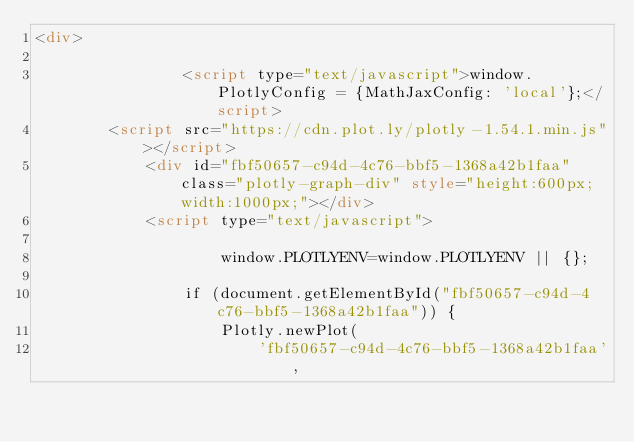<code> <loc_0><loc_0><loc_500><loc_500><_HTML_><div>
        
                <script type="text/javascript">window.PlotlyConfig = {MathJaxConfig: 'local'};</script>
        <script src="https://cdn.plot.ly/plotly-1.54.1.min.js"></script>    
            <div id="fbf50657-c94d-4c76-bbf5-1368a42b1faa" class="plotly-graph-div" style="height:600px; width:1000px;"></div>
            <script type="text/javascript">
                
                    window.PLOTLYENV=window.PLOTLYENV || {};
                    
                if (document.getElementById("fbf50657-c94d-4c76-bbf5-1368a42b1faa")) {
                    Plotly.newPlot(
                        'fbf50657-c94d-4c76-bbf5-1368a42b1faa',</code> 